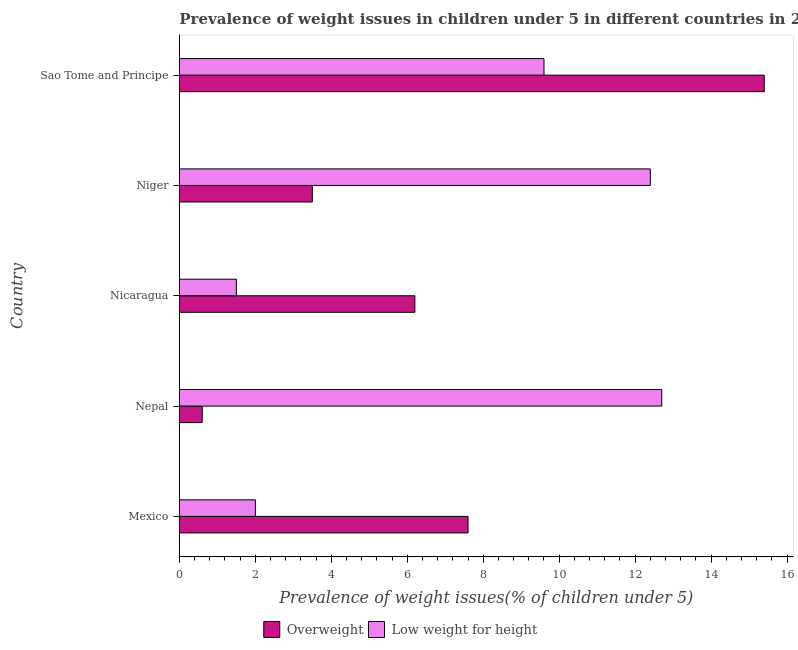How many different coloured bars are there?
Provide a short and direct response. 2. How many groups of bars are there?
Ensure brevity in your answer.  5. Are the number of bars per tick equal to the number of legend labels?
Give a very brief answer. Yes. Are the number of bars on each tick of the Y-axis equal?
Ensure brevity in your answer.  Yes. How many bars are there on the 1st tick from the top?
Keep it short and to the point. 2. What is the label of the 2nd group of bars from the top?
Offer a terse response. Niger. What is the percentage of underweight children in Sao Tome and Principe?
Provide a short and direct response. 9.6. Across all countries, what is the maximum percentage of overweight children?
Your answer should be compact. 15.4. Across all countries, what is the minimum percentage of overweight children?
Provide a succinct answer. 0.6. In which country was the percentage of underweight children maximum?
Give a very brief answer. Nepal. In which country was the percentage of underweight children minimum?
Your response must be concise. Nicaragua. What is the total percentage of underweight children in the graph?
Offer a very short reply. 38.2. What is the difference between the percentage of overweight children in Niger and the percentage of underweight children in Nicaragua?
Ensure brevity in your answer.  2. What is the average percentage of underweight children per country?
Offer a terse response. 7.64. What is the difference between the percentage of overweight children and percentage of underweight children in Nicaragua?
Offer a very short reply. 4.7. What is the ratio of the percentage of overweight children in Mexico to that in Nicaragua?
Keep it short and to the point. 1.23. What is the difference between the highest and the lowest percentage of underweight children?
Offer a terse response. 11.2. Is the sum of the percentage of overweight children in Nepal and Niger greater than the maximum percentage of underweight children across all countries?
Make the answer very short. No. What does the 1st bar from the top in Nepal represents?
Provide a succinct answer. Low weight for height. What does the 1st bar from the bottom in Mexico represents?
Offer a very short reply. Overweight. Are all the bars in the graph horizontal?
Ensure brevity in your answer.  Yes. Are the values on the major ticks of X-axis written in scientific E-notation?
Give a very brief answer. No. Does the graph contain grids?
Make the answer very short. No. How many legend labels are there?
Ensure brevity in your answer.  2. How are the legend labels stacked?
Your answer should be compact. Horizontal. What is the title of the graph?
Ensure brevity in your answer.  Prevalence of weight issues in children under 5 in different countries in 2006. Does "Underweight" appear as one of the legend labels in the graph?
Your response must be concise. No. What is the label or title of the X-axis?
Offer a very short reply. Prevalence of weight issues(% of children under 5). What is the label or title of the Y-axis?
Make the answer very short. Country. What is the Prevalence of weight issues(% of children under 5) in Overweight in Mexico?
Keep it short and to the point. 7.6. What is the Prevalence of weight issues(% of children under 5) of Overweight in Nepal?
Make the answer very short. 0.6. What is the Prevalence of weight issues(% of children under 5) in Low weight for height in Nepal?
Provide a succinct answer. 12.7. What is the Prevalence of weight issues(% of children under 5) in Overweight in Nicaragua?
Your answer should be compact. 6.2. What is the Prevalence of weight issues(% of children under 5) in Low weight for height in Nicaragua?
Your response must be concise. 1.5. What is the Prevalence of weight issues(% of children under 5) of Overweight in Niger?
Make the answer very short. 3.5. What is the Prevalence of weight issues(% of children under 5) in Low weight for height in Niger?
Keep it short and to the point. 12.4. What is the Prevalence of weight issues(% of children under 5) in Overweight in Sao Tome and Principe?
Offer a very short reply. 15.4. What is the Prevalence of weight issues(% of children under 5) in Low weight for height in Sao Tome and Principe?
Make the answer very short. 9.6. Across all countries, what is the maximum Prevalence of weight issues(% of children under 5) in Overweight?
Your answer should be very brief. 15.4. Across all countries, what is the maximum Prevalence of weight issues(% of children under 5) of Low weight for height?
Make the answer very short. 12.7. Across all countries, what is the minimum Prevalence of weight issues(% of children under 5) in Overweight?
Provide a succinct answer. 0.6. What is the total Prevalence of weight issues(% of children under 5) of Overweight in the graph?
Offer a very short reply. 33.3. What is the total Prevalence of weight issues(% of children under 5) of Low weight for height in the graph?
Your answer should be very brief. 38.2. What is the difference between the Prevalence of weight issues(% of children under 5) in Overweight in Mexico and that in Nicaragua?
Ensure brevity in your answer.  1.4. What is the difference between the Prevalence of weight issues(% of children under 5) in Overweight in Mexico and that in Sao Tome and Principe?
Your answer should be compact. -7.8. What is the difference between the Prevalence of weight issues(% of children under 5) of Low weight for height in Mexico and that in Sao Tome and Principe?
Keep it short and to the point. -7.6. What is the difference between the Prevalence of weight issues(% of children under 5) of Overweight in Nepal and that in Niger?
Offer a very short reply. -2.9. What is the difference between the Prevalence of weight issues(% of children under 5) of Overweight in Nepal and that in Sao Tome and Principe?
Offer a very short reply. -14.8. What is the difference between the Prevalence of weight issues(% of children under 5) of Overweight in Nicaragua and that in Niger?
Keep it short and to the point. 2.7. What is the difference between the Prevalence of weight issues(% of children under 5) in Low weight for height in Niger and that in Sao Tome and Principe?
Your answer should be compact. 2.8. What is the difference between the Prevalence of weight issues(% of children under 5) of Overweight in Mexico and the Prevalence of weight issues(% of children under 5) of Low weight for height in Sao Tome and Principe?
Provide a short and direct response. -2. What is the difference between the Prevalence of weight issues(% of children under 5) of Overweight in Nepal and the Prevalence of weight issues(% of children under 5) of Low weight for height in Nicaragua?
Provide a succinct answer. -0.9. What is the difference between the Prevalence of weight issues(% of children under 5) of Overweight in Nepal and the Prevalence of weight issues(% of children under 5) of Low weight for height in Niger?
Your answer should be compact. -11.8. What is the difference between the Prevalence of weight issues(% of children under 5) of Overweight in Niger and the Prevalence of weight issues(% of children under 5) of Low weight for height in Sao Tome and Principe?
Your answer should be very brief. -6.1. What is the average Prevalence of weight issues(% of children under 5) in Overweight per country?
Offer a terse response. 6.66. What is the average Prevalence of weight issues(% of children under 5) in Low weight for height per country?
Your answer should be compact. 7.64. What is the difference between the Prevalence of weight issues(% of children under 5) in Overweight and Prevalence of weight issues(% of children under 5) in Low weight for height in Nicaragua?
Offer a very short reply. 4.7. What is the difference between the Prevalence of weight issues(% of children under 5) in Overweight and Prevalence of weight issues(% of children under 5) in Low weight for height in Sao Tome and Principe?
Offer a terse response. 5.8. What is the ratio of the Prevalence of weight issues(% of children under 5) of Overweight in Mexico to that in Nepal?
Ensure brevity in your answer.  12.67. What is the ratio of the Prevalence of weight issues(% of children under 5) of Low weight for height in Mexico to that in Nepal?
Offer a very short reply. 0.16. What is the ratio of the Prevalence of weight issues(% of children under 5) of Overweight in Mexico to that in Nicaragua?
Give a very brief answer. 1.23. What is the ratio of the Prevalence of weight issues(% of children under 5) in Overweight in Mexico to that in Niger?
Your answer should be compact. 2.17. What is the ratio of the Prevalence of weight issues(% of children under 5) of Low weight for height in Mexico to that in Niger?
Keep it short and to the point. 0.16. What is the ratio of the Prevalence of weight issues(% of children under 5) of Overweight in Mexico to that in Sao Tome and Principe?
Offer a very short reply. 0.49. What is the ratio of the Prevalence of weight issues(% of children under 5) in Low weight for height in Mexico to that in Sao Tome and Principe?
Keep it short and to the point. 0.21. What is the ratio of the Prevalence of weight issues(% of children under 5) of Overweight in Nepal to that in Nicaragua?
Ensure brevity in your answer.  0.1. What is the ratio of the Prevalence of weight issues(% of children under 5) in Low weight for height in Nepal to that in Nicaragua?
Make the answer very short. 8.47. What is the ratio of the Prevalence of weight issues(% of children under 5) of Overweight in Nepal to that in Niger?
Give a very brief answer. 0.17. What is the ratio of the Prevalence of weight issues(% of children under 5) of Low weight for height in Nepal to that in Niger?
Offer a terse response. 1.02. What is the ratio of the Prevalence of weight issues(% of children under 5) in Overweight in Nepal to that in Sao Tome and Principe?
Keep it short and to the point. 0.04. What is the ratio of the Prevalence of weight issues(% of children under 5) in Low weight for height in Nepal to that in Sao Tome and Principe?
Give a very brief answer. 1.32. What is the ratio of the Prevalence of weight issues(% of children under 5) of Overweight in Nicaragua to that in Niger?
Make the answer very short. 1.77. What is the ratio of the Prevalence of weight issues(% of children under 5) of Low weight for height in Nicaragua to that in Niger?
Offer a very short reply. 0.12. What is the ratio of the Prevalence of weight issues(% of children under 5) in Overweight in Nicaragua to that in Sao Tome and Principe?
Your answer should be compact. 0.4. What is the ratio of the Prevalence of weight issues(% of children under 5) of Low weight for height in Nicaragua to that in Sao Tome and Principe?
Your answer should be compact. 0.16. What is the ratio of the Prevalence of weight issues(% of children under 5) of Overweight in Niger to that in Sao Tome and Principe?
Your response must be concise. 0.23. What is the ratio of the Prevalence of weight issues(% of children under 5) of Low weight for height in Niger to that in Sao Tome and Principe?
Your response must be concise. 1.29. What is the difference between the highest and the second highest Prevalence of weight issues(% of children under 5) in Low weight for height?
Your answer should be compact. 0.3. 